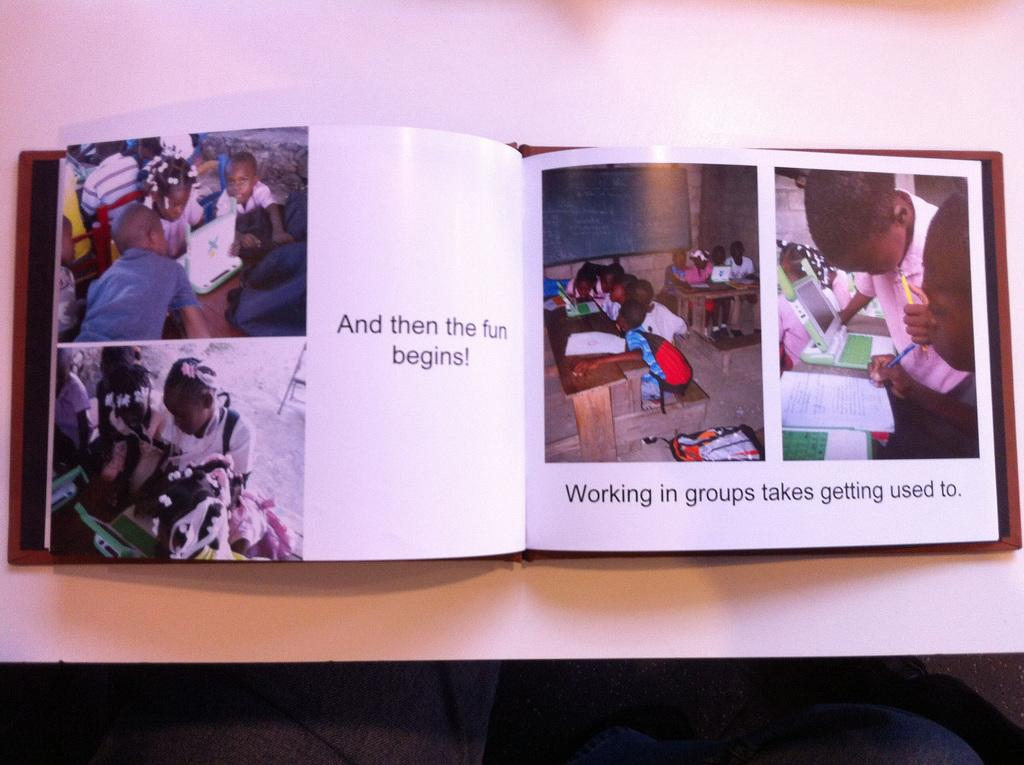<image>
Offer a succinct explanation of the picture presented. A book is open to children with the caption "And then the fun Begins!". 